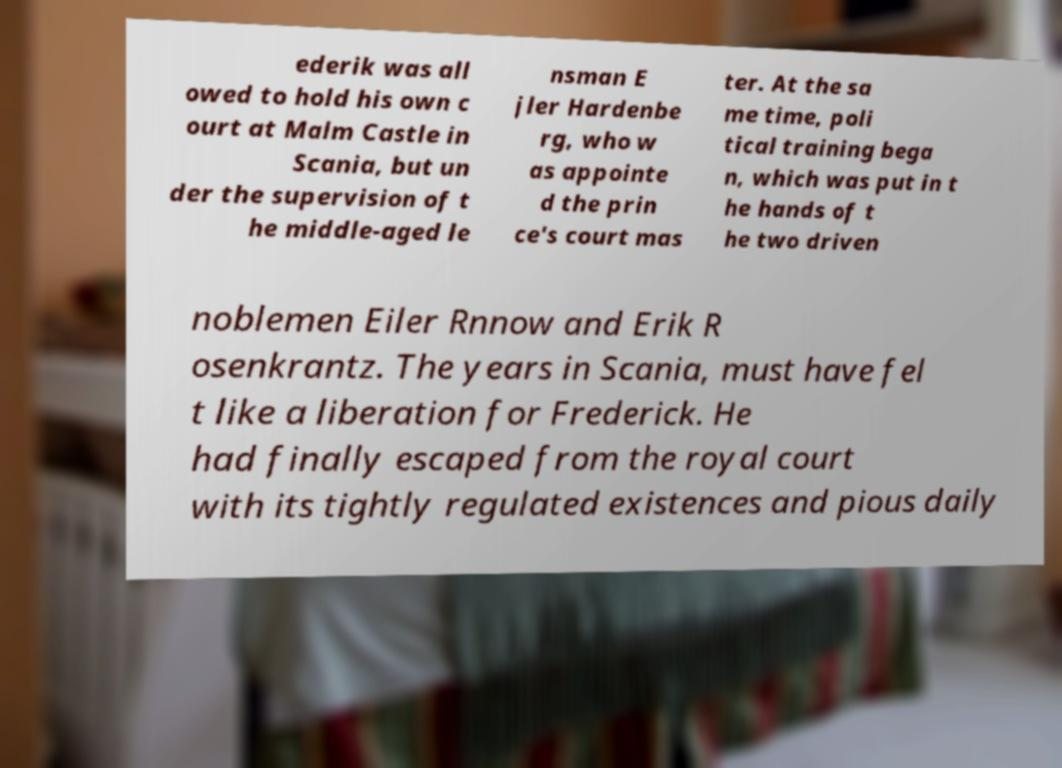Could you assist in decoding the text presented in this image and type it out clearly? ederik was all owed to hold his own c ourt at Malm Castle in Scania, but un der the supervision of t he middle-aged le nsman E jler Hardenbe rg, who w as appointe d the prin ce's court mas ter. At the sa me time, poli tical training bega n, which was put in t he hands of t he two driven noblemen Eiler Rnnow and Erik R osenkrantz. The years in Scania, must have fel t like a liberation for Frederick. He had finally escaped from the royal court with its tightly regulated existences and pious daily 